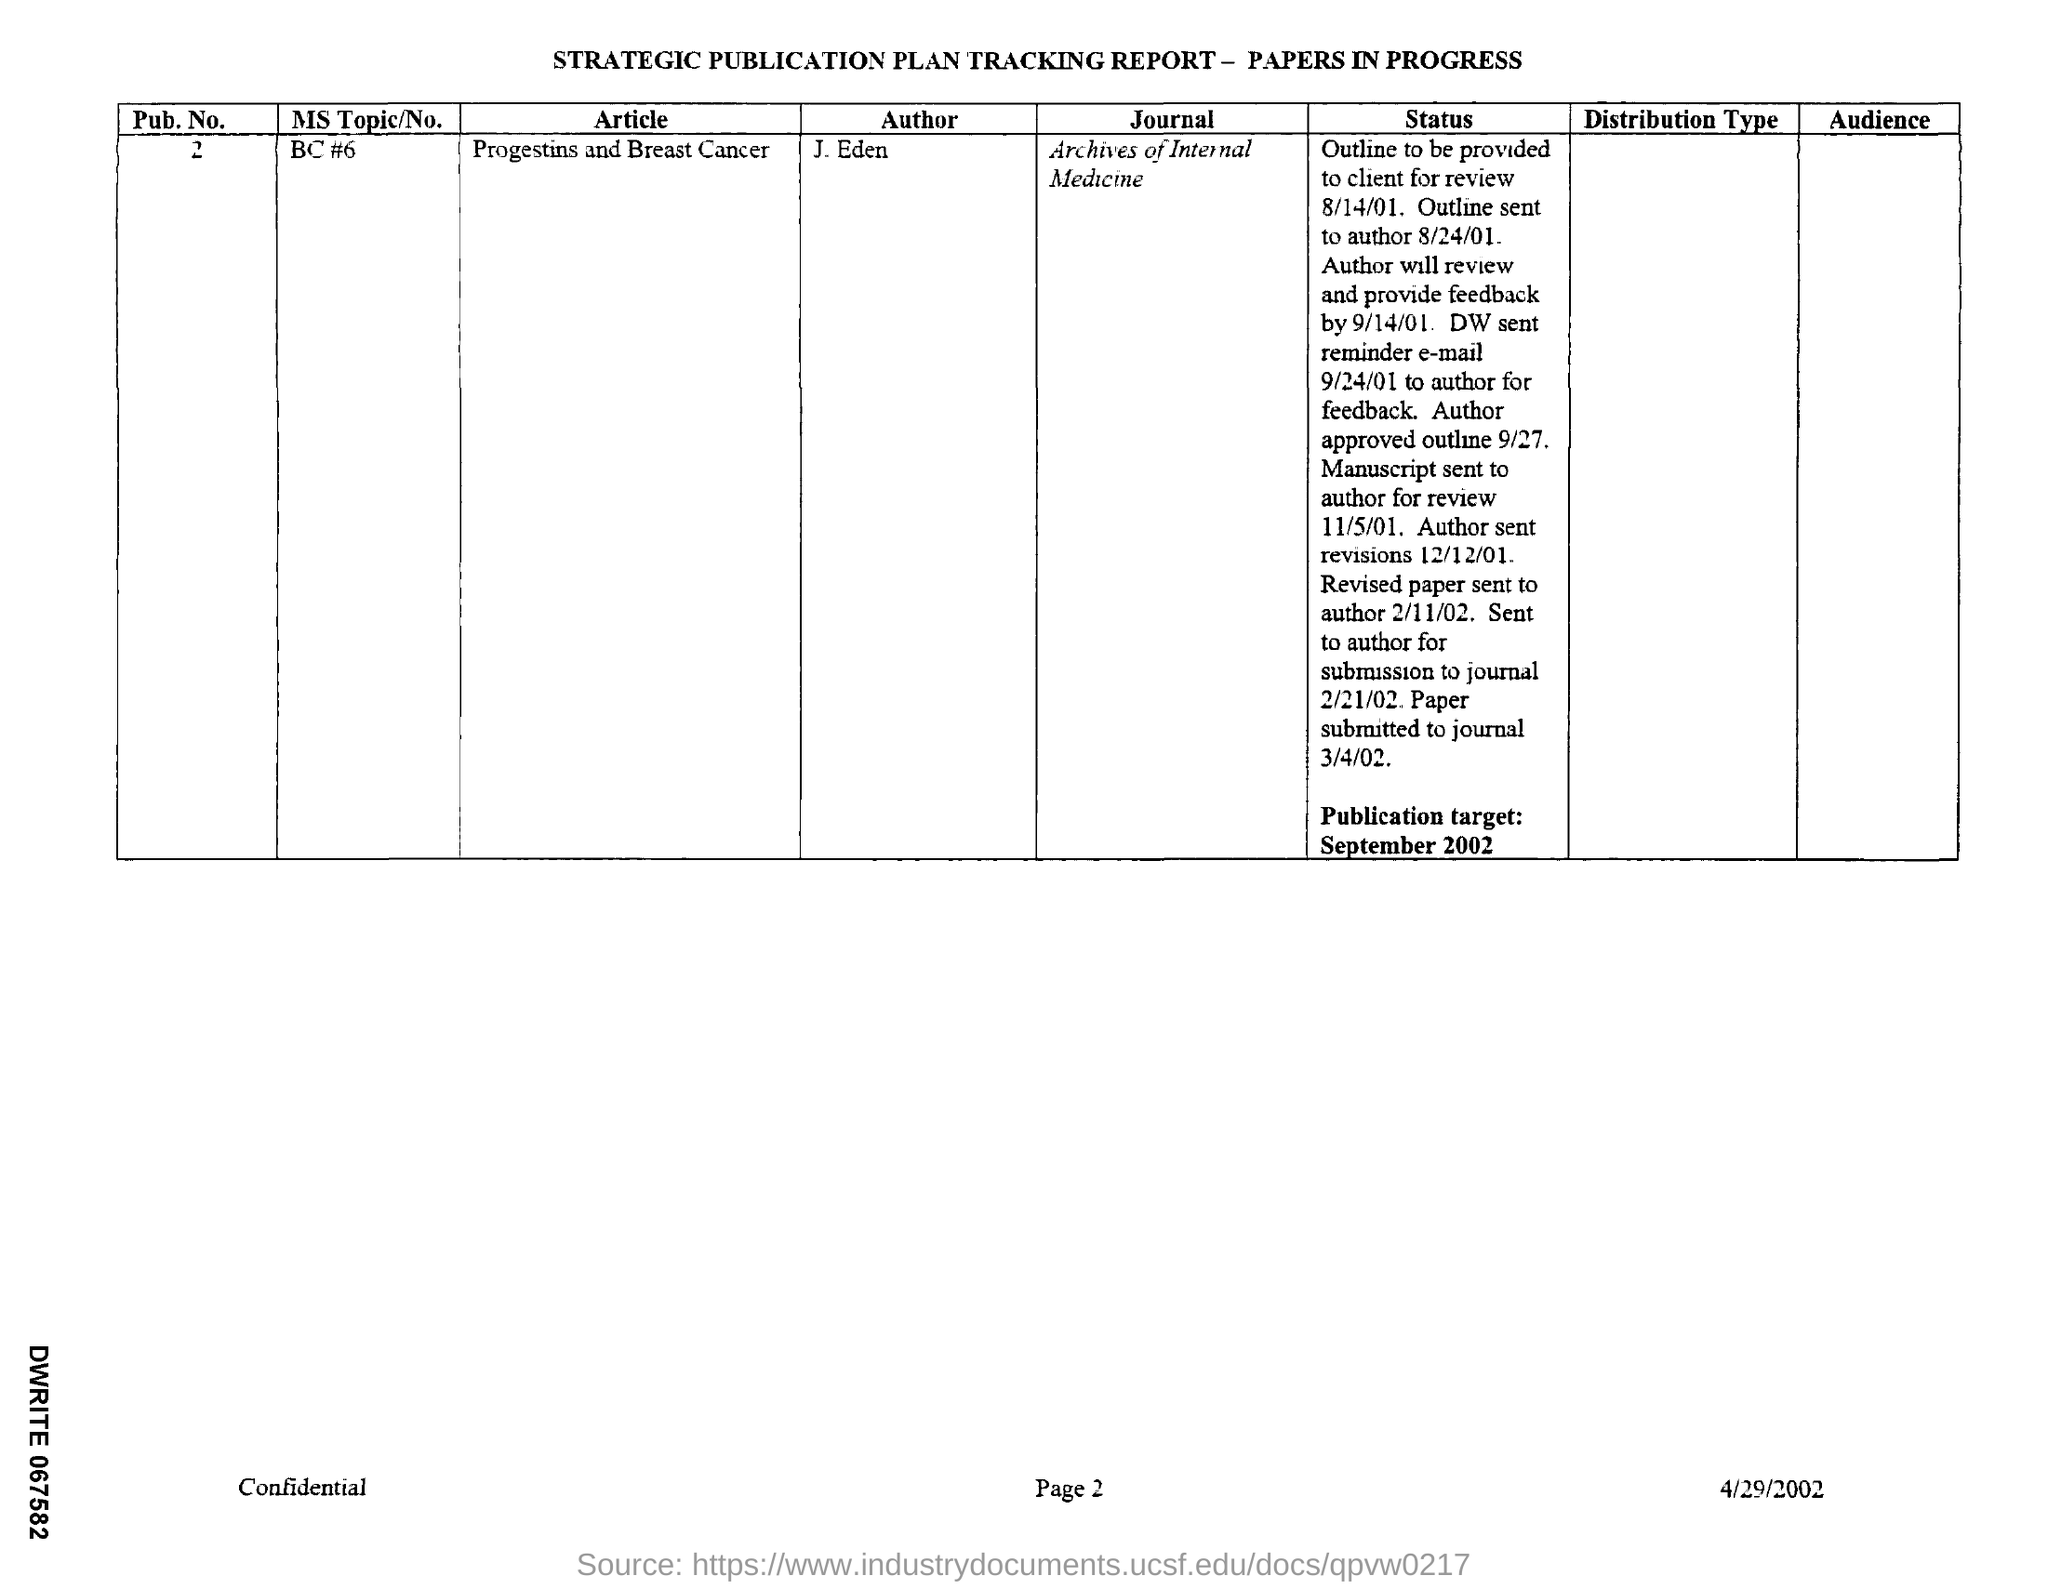In which Journal is the paper going to published?
 archives of internal medicine 